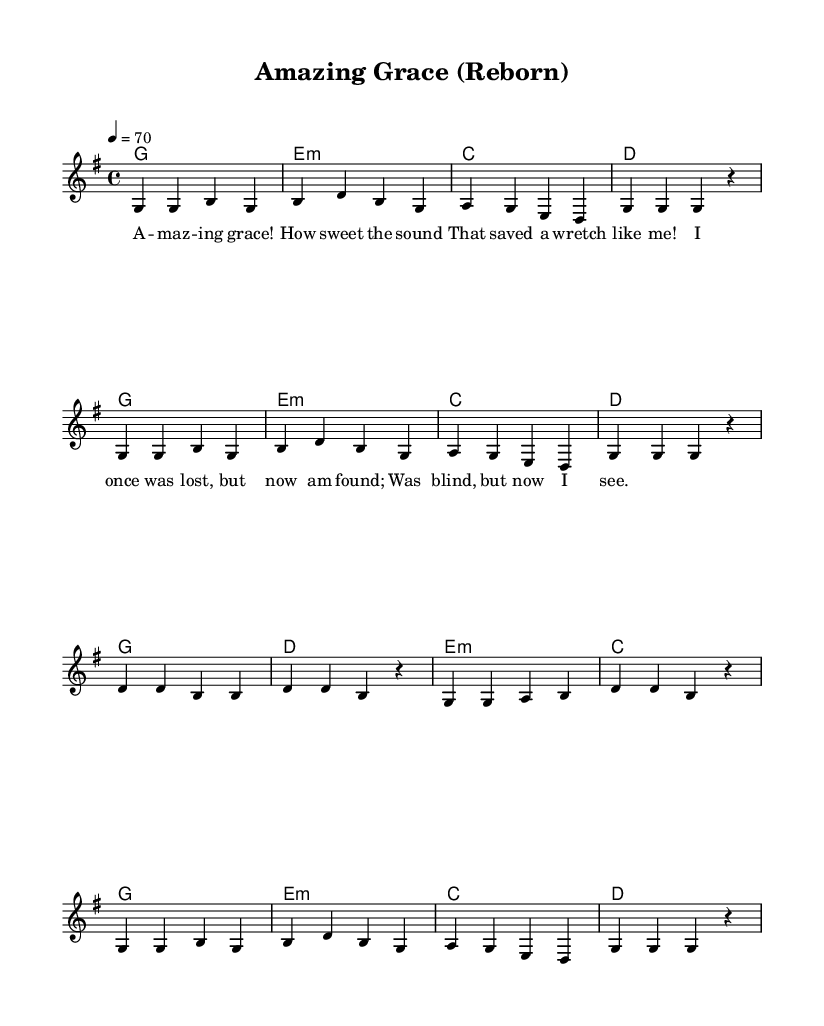What is the key signature of this music? The key signature of the music is G major, which has one sharp (F#). This can be inferred from the "g \major" indicated after the "global" declaration.
Answer: G major What is the time signature of the piece? The time signature of the piece is 4/4, indicated by the notation "/4/4" in the "global" section. This means there are four beats per measure, and the quarter note gets one beat.
Answer: 4/4 What is the tempo marking for this music? The tempo marking is indicated as "4 = 70" in the "global" section, which specifies that the quarter note should be played at a speed of 70 beats per minute.
Answer: 70 How many verses are in the melody? The melody has two repetitions of the verse section, indicated by the structure of the notes and the lyrics provided after the first verse. Each verse consists of 8 measures.
Answer: 2 What is the main emotion conveyed in the lyrics? The lyrics convey a sense of redemption and gratitude, as they speak of discovering grace and being found after being lost, a common theme in soulful worship music.
Answer: Redemption What harmonies accompany the chorus? The harmonies for the chorus are G major, D major, E minor, and C major as indicated in the chord progression in the "harmonies" section, creating a typical soulful feel.
Answer: G, D, E minor, C 